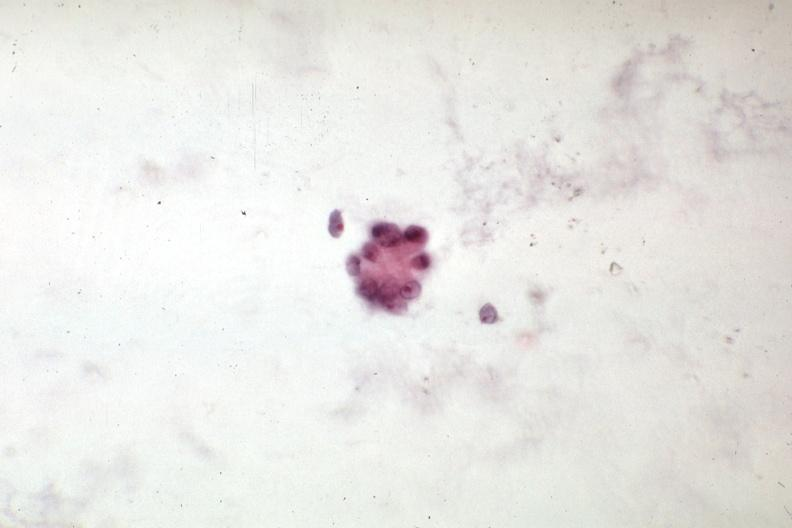what is present?
Answer the question using a single word or phrase. Peritoneal fluid 